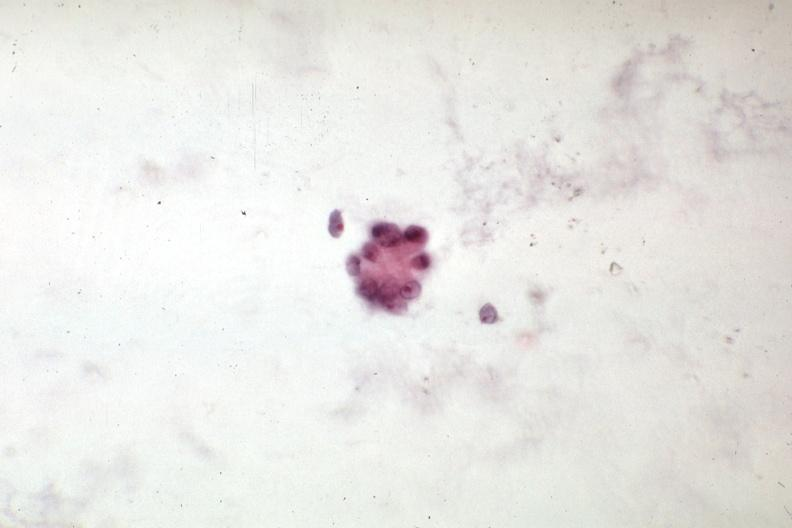what is present?
Answer the question using a single word or phrase. Peritoneal fluid 